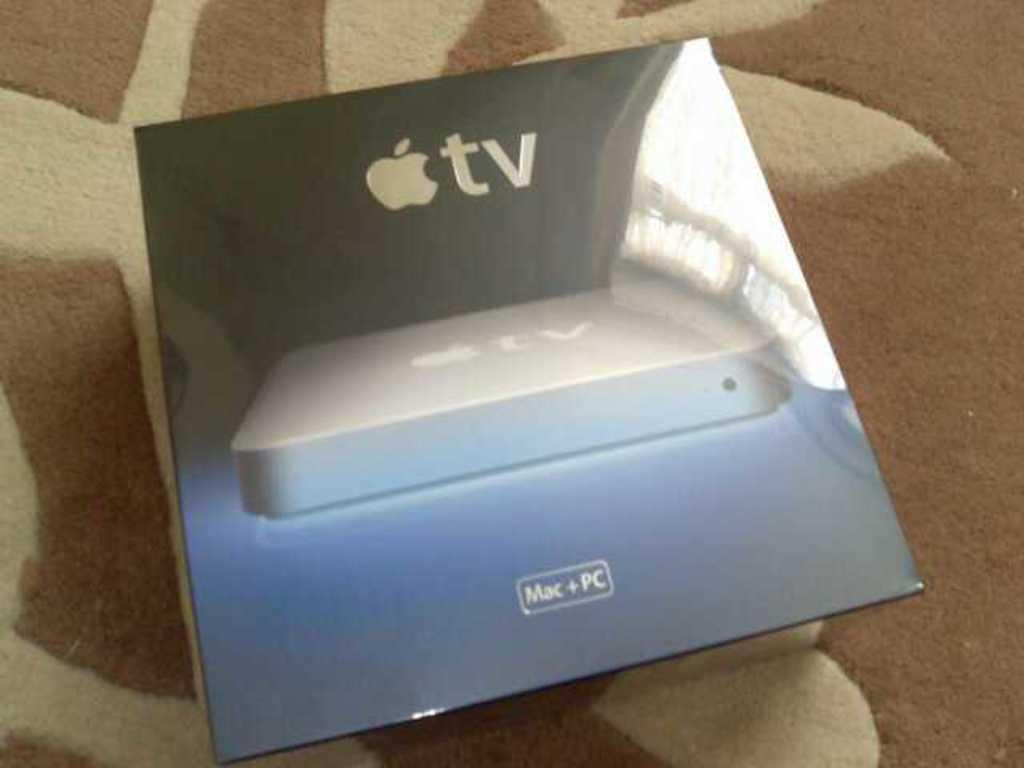<image>
Provide a brief description of the given image. The box contains an Apple TV device for use with Mac or PC. 